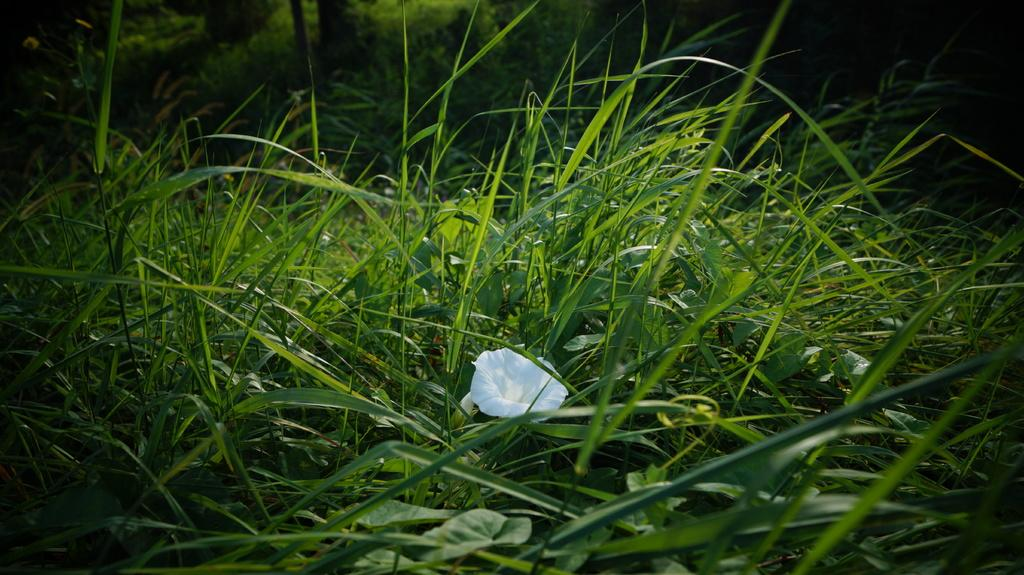What is the dominant feature of the landscape in the image? There is a lot of grass in the image. Can you identify any specific plants or flowers in the grass? Yes, there is a white flower in the grass. What type of trouble is the doctor experiencing with the worm in the image? There is no doctor, worm, or any indication of trouble in the image; it only features grass and a white flower. 